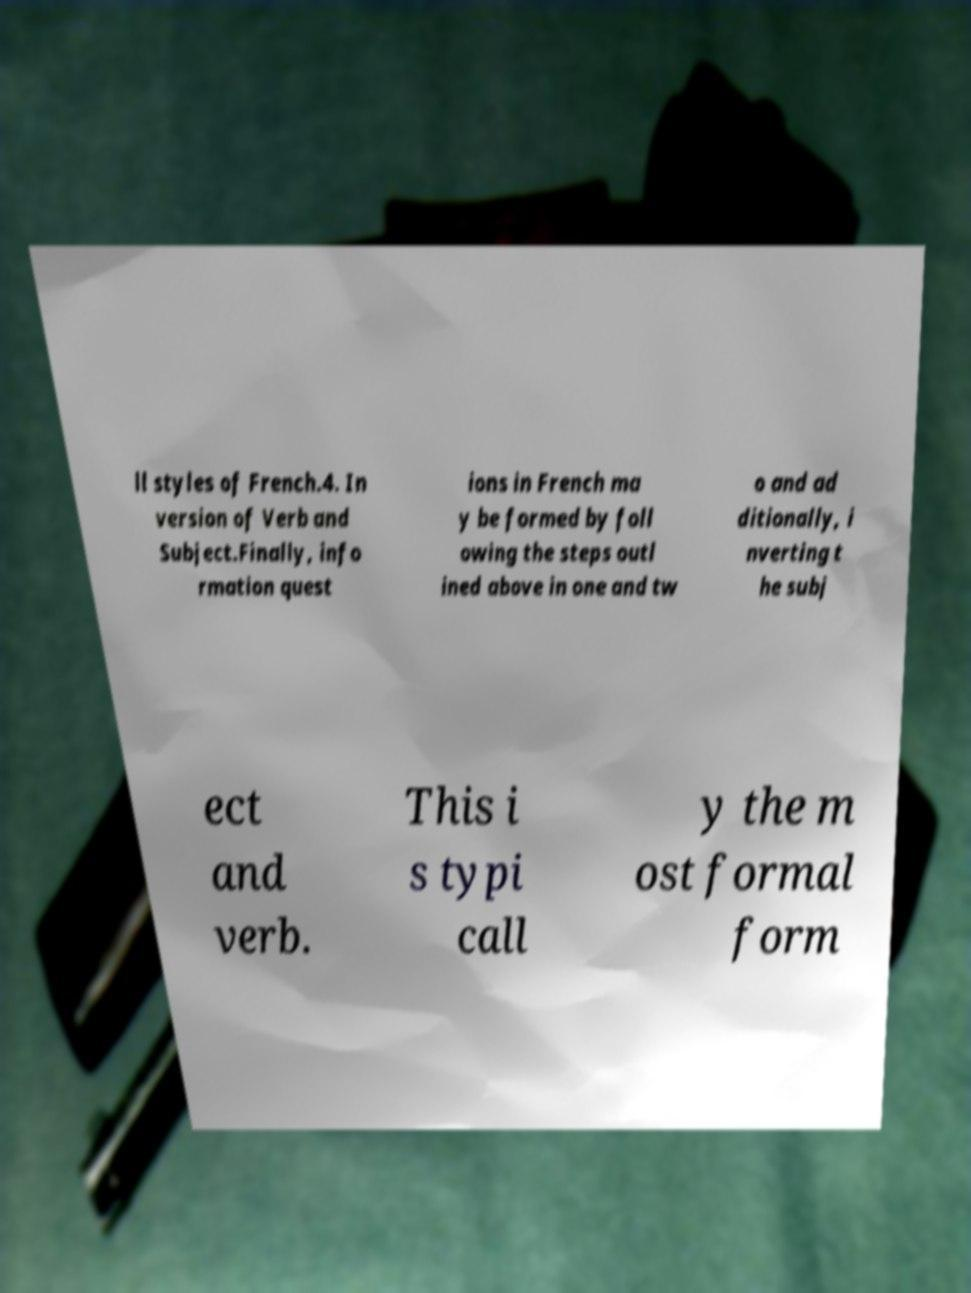Can you accurately transcribe the text from the provided image for me? ll styles of French.4. In version of Verb and Subject.Finally, info rmation quest ions in French ma y be formed by foll owing the steps outl ined above in one and tw o and ad ditionally, i nverting t he subj ect and verb. This i s typi call y the m ost formal form 